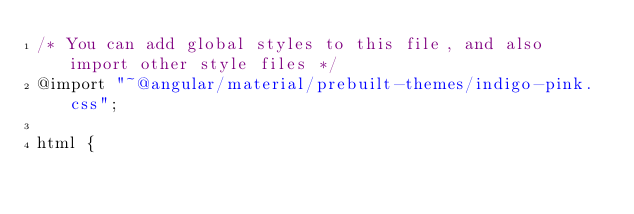<code> <loc_0><loc_0><loc_500><loc_500><_CSS_>/* You can add global styles to this file, and also import other style files */
@import "~@angular/material/prebuilt-themes/indigo-pink.css";

html { </code> 